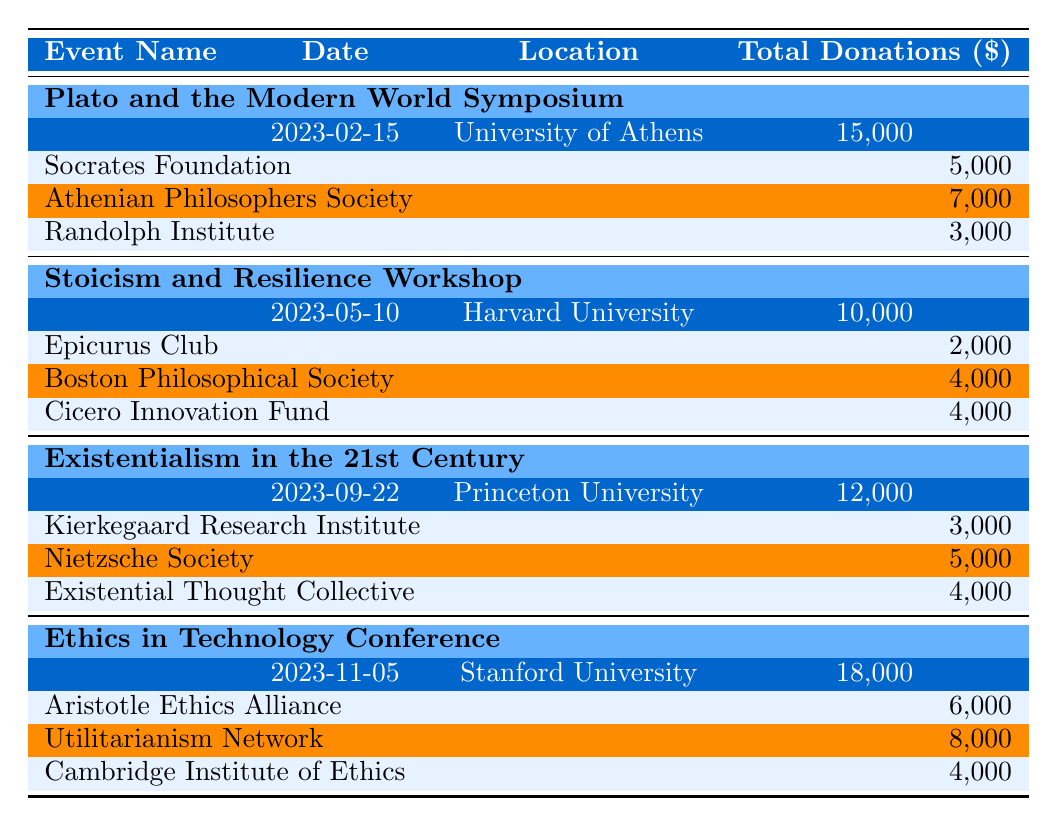What is the total amount donated for the "Plato and the Modern World Symposium"? The table states that the total amount donated for the event "Plato and the Modern World Symposium" is listed as 15,000 dollars.
Answer: 15,000 Who made the largest donation to the "Ethics in Technology Conference"? According to the table, the largest donation for the "Ethics in Technology Conference" comes from the "Utilitarianism Network," which donated 8,000 dollars.
Answer: Utilitarianism Network How much did the "Existential Thought Collective" donate? The table indicates that "Existential Thought Collective" donated 4,000 dollars for the event “Existentialism in the 21st Century.”
Answer: 4,000 What is the average donation amount for all events? To calculate the average donation amount, we first add all total donations: 15,000 + 10,000 + 12,000 + 18,000 = 55,000. There are 4 events, so the average is 55,000 divided by 4, which equals 13,750.
Answer: 13,750 Is the total donations amount for "Stoicism and Resilience Workshop" greater than that for "Existentialism in the 21st Century"? The "Stoicism and Resilience Workshop" has total donations of 10,000 dollars, while "Existentialism in the 21st Century" has 12,000 dollars. Since 10,000 is not greater than 12,000, the statement is false.
Answer: No What is the combined total donation amount of the "Athenian Philosophers Society" and "Randolph Institute"? From the table, "Athenian Philosophers Society" donated 7,000 dollars and "Randolph Institute" donated 3,000 dollars. Adding these amounts together gives 7,000 + 3,000 = 10,000.
Answer: 10,000 Which event received the least total donations? By examining the total donations for each event, we find: 15,000 for Plato, 10,000 for Stoicism, 12,000 for Existentialism, and 18,000 for Ethics. Thus, the event with the least total donations is the "Stoicism and Resilience Workshop."
Answer: Stoicism and Resilience Workshop How much did the "Cambridge Institute of Ethics" donate? The table shows that the "Cambridge Institute of Ethics" donated 4,000 dollars for the "Ethics in Technology Conference."
Answer: 4,000 Which city hosted the "Existentialism in the 21st Century" event? The table indicates that "Existentialism in the 21st Century" was held at Princeton University, located in Princeton.
Answer: Princeton 